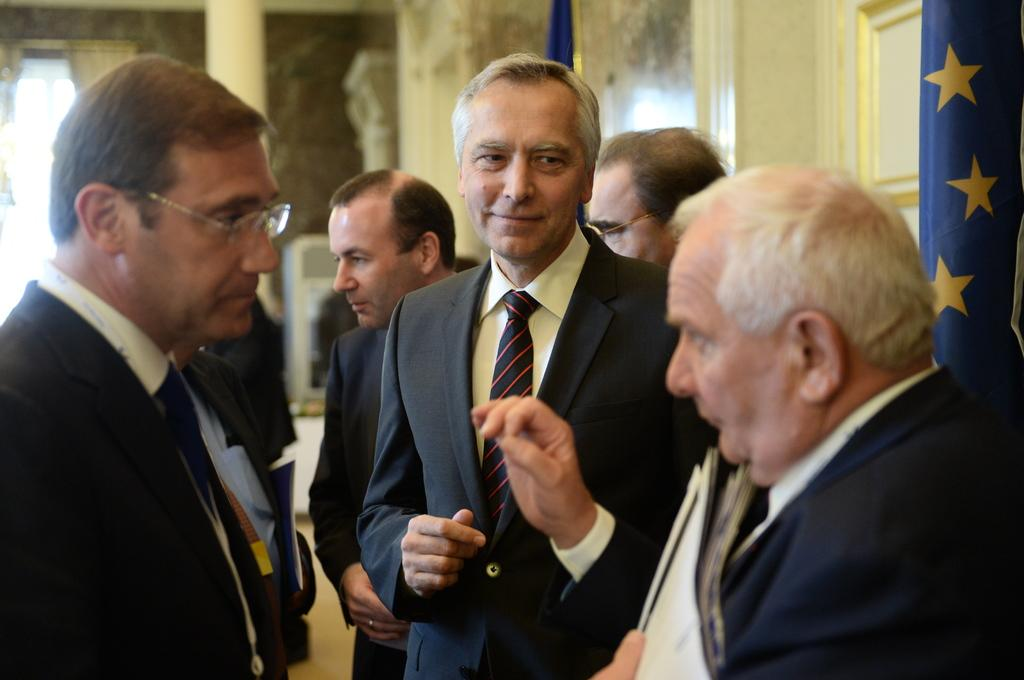What is the main subject in the foreground of the image? There is a group of men in the foreground of the image. What are the men doing in the image? The men are standing. What can be seen on the right side of the image? There is a flag on the right side of the image. How is the background of the men depicted in the image? The background of the men is blurred. How many dimes can be seen on the ground near the men in the image? There are no dimes visible on the ground near the men in the image. What type of smile can be seen on the faces of the men in the image? There is no indication of facial expressions, such as smiles, on the faces of the men in the image. 